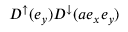Convert formula to latex. <formula><loc_0><loc_0><loc_500><loc_500>D ^ { \uparrow } ( e _ { y } ) D ^ { \downarrow } ( a e _ { x } e _ { y } )</formula> 